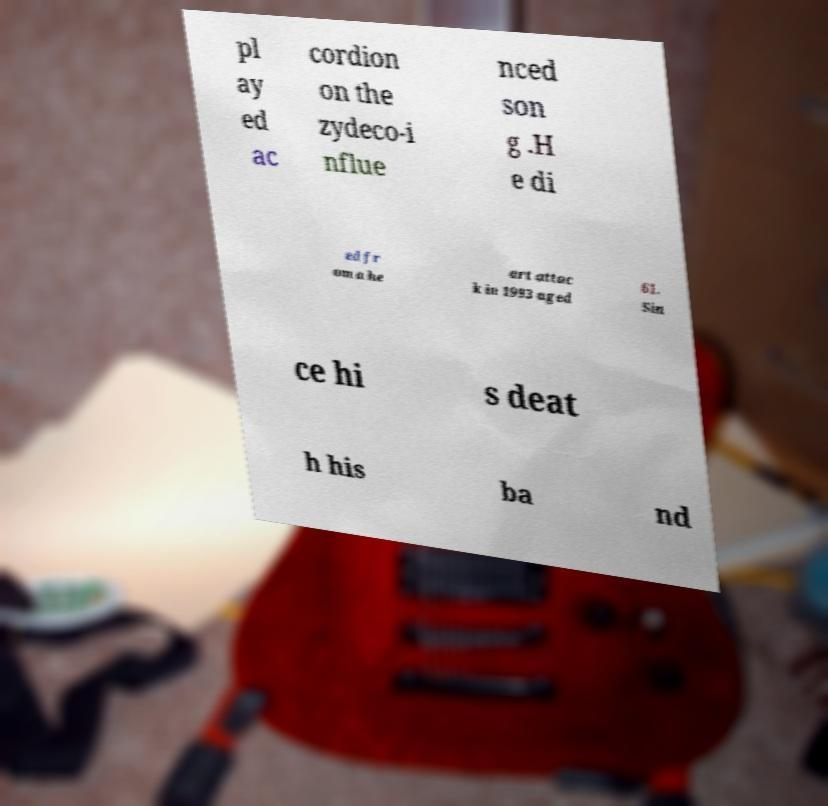Could you extract and type out the text from this image? pl ay ed ac cordion on the zydeco-i nflue nced son g .H e di ed fr om a he art attac k in 1993 aged 61. Sin ce hi s deat h his ba nd 